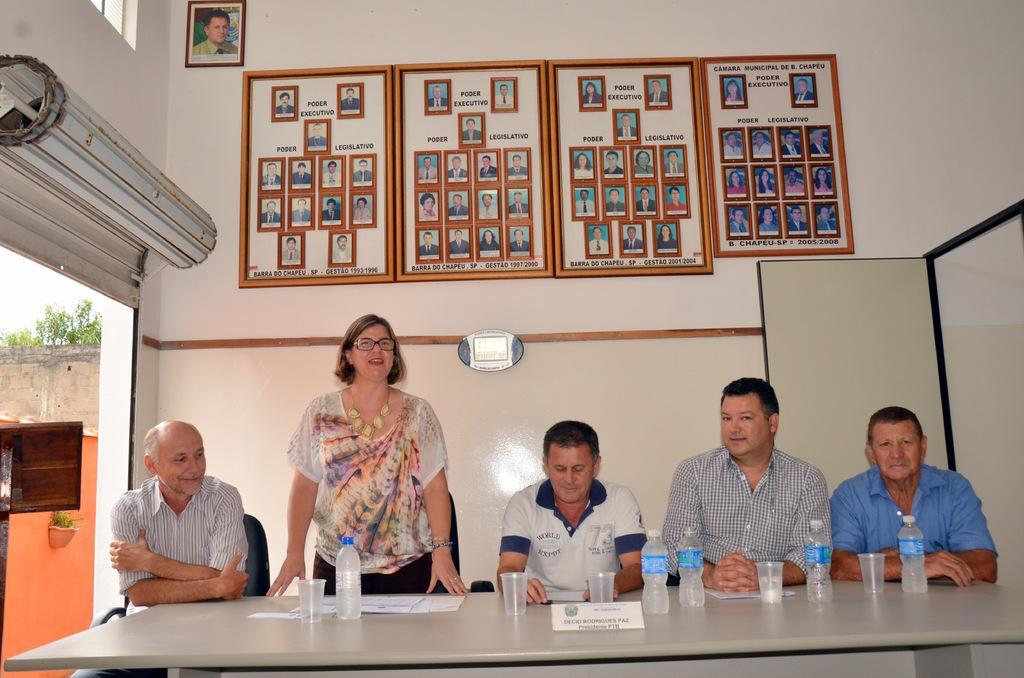Please provide a concise description of this image. This picture shows few people seated on a chairs and a woman standing and speaking and we see glasses ,papers and water bottles on the table and we see few photo frames on the wall and we see a door on the right side can we see a tree 